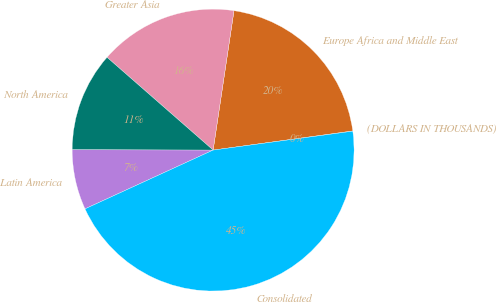<chart> <loc_0><loc_0><loc_500><loc_500><pie_chart><fcel>(DOLLARS IN THOUSANDS)<fcel>Europe Africa and Middle East<fcel>Greater Asia<fcel>North America<fcel>Latin America<fcel>Consolidated<nl><fcel>0.03%<fcel>20.46%<fcel>15.93%<fcel>11.4%<fcel>6.88%<fcel>45.29%<nl></chart> 